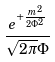Convert formula to latex. <formula><loc_0><loc_0><loc_500><loc_500>\frac { e ^ { + \frac { m ^ { 2 } } { 2 \Phi ^ { 2 } } } } { \sqrt { 2 \pi } \Phi }</formula> 